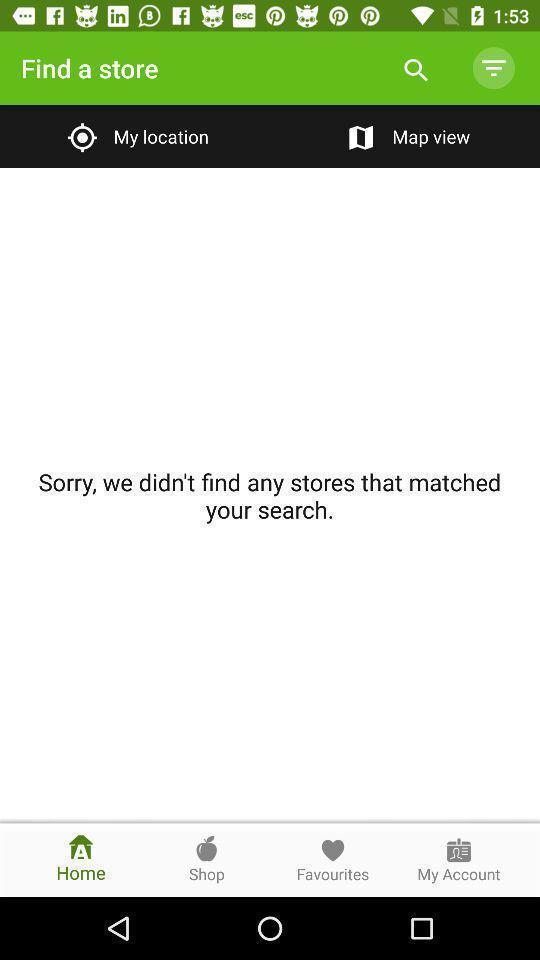What can you discern from this picture? Screen page displaying multiple options in location app. 